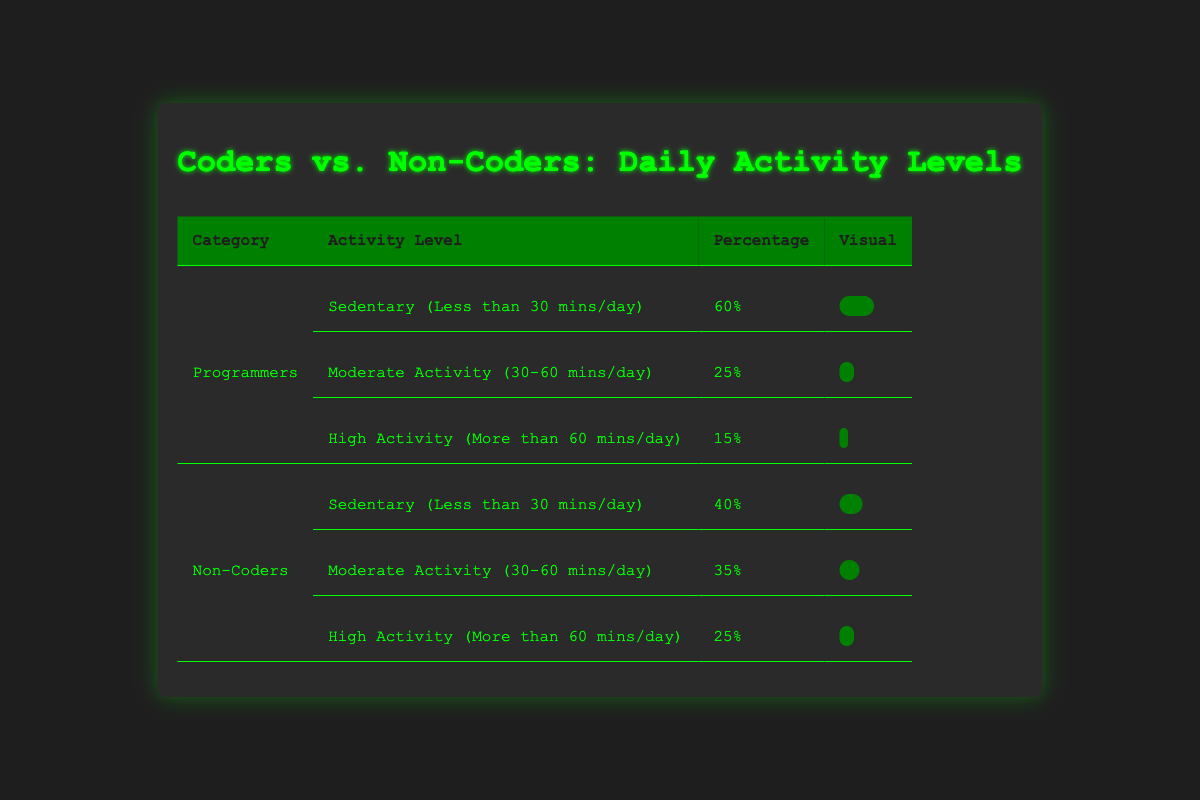What percentage of programmers engage in high physical activity (more than 60 mins/day)? From the table, the row for "High Activity (More than 60 mins/day)" under the "Programmers" category shows a percentage of 15%.
Answer: 15% How does the sedentary percentage of non-coders compare to that of programmers? The sedentary percentage for non-coders is 40%, and for programmers, it is 60%. Thus, non-coders are 20% less sedentary than programmers.
Answer: Non-coders are 20% less sedentary What is the total percentage of programmers who are moderately active (30-60 mins/day) or highly active (more than 60 mins/day)? The percentage of moderately active programmers is 25% and for highly active is 15%. Adding these gives 25% + 15% = 40%.
Answer: 40% True or False: More than half of non-coders are sedentary. The sedentary percentage for non-coders is 40%, which is not more than half (50%).
Answer: False Which group has a higher rate of moderate activity (30-60 mins/day), coders or non-coders? Programmers show a moderate activity percentage of 25%, while non-coders have a moderate activity percentage of 35%. Thus, non-coders have a higher rate of moderate activity.
Answer: Non-coders have a higher rate What is the difference between the percentage of sedentary programmers and sedentary non-coders? Sedentary programmers make up 60% while sedentary non-coders account for 40%. The difference is 60% - 40% = 20%.
Answer: 20% If you add the high activity percentages of both groups, what do you get? The high activity percentage for programmers is 15% and for non-coders, it is 25%. Adding these gives 15% + 25% = 40%.
Answer: 40% What percentage of coders are not sedentary? Programmers are 60% sedentary, meaning they are 40% not sedentary (100% - 60% = 40%).
Answer: 40% Is the percentage of high activity for non-coders greater than that for programmers? For non-coders, the high activity percentage is 25% and for programmers, it is 15%. Since 25% is greater than 15%, the statement is true.
Answer: Yes, it is greater What is the overall percentage of coders who are at least moderately active or highly active? The percentage of moderately active is 25% and high activity is 15%, combined as 25% + 15% = 40%.
Answer: 40% 